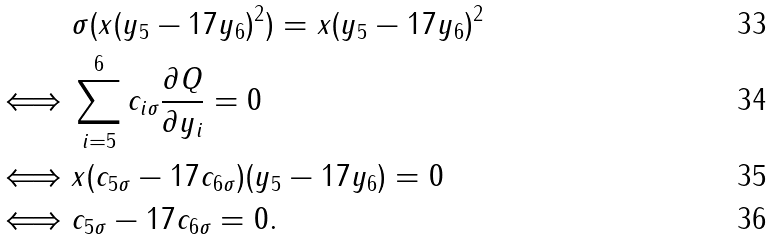<formula> <loc_0><loc_0><loc_500><loc_500>& \sigma ( x ( y _ { 5 } - 1 7 y _ { 6 } ) ^ { 2 } ) = x ( y _ { 5 } - 1 7 y _ { 6 } ) ^ { 2 } \\ \iff & \sum ^ { 6 } _ { i = 5 } c _ { i \sigma } \frac { \partial Q } { \partial y _ { i } } = 0 \\ \iff & x ( c _ { 5 \sigma } - 1 7 c _ { 6 \sigma } ) ( y _ { 5 } - 1 7 y _ { 6 } ) = 0 \\ \iff & c _ { 5 \sigma } - 1 7 c _ { 6 \sigma } = 0 .</formula> 